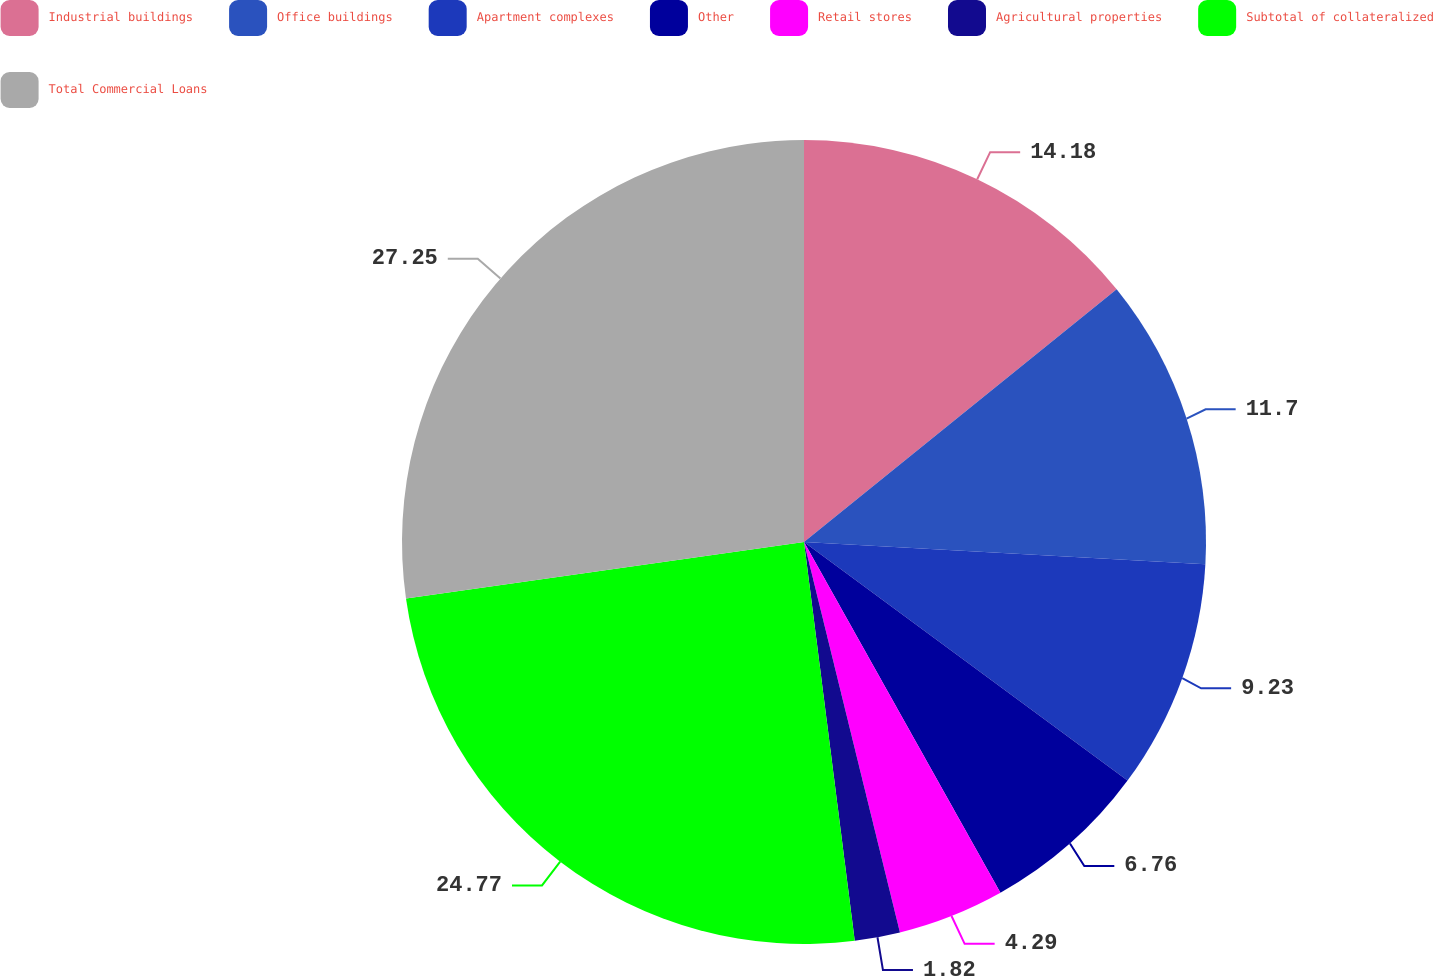Convert chart. <chart><loc_0><loc_0><loc_500><loc_500><pie_chart><fcel>Industrial buildings<fcel>Office buildings<fcel>Apartment complexes<fcel>Other<fcel>Retail stores<fcel>Agricultural properties<fcel>Subtotal of collateralized<fcel>Total Commercial Loans<nl><fcel>14.18%<fcel>11.7%<fcel>9.23%<fcel>6.76%<fcel>4.29%<fcel>1.82%<fcel>24.77%<fcel>27.24%<nl></chart> 